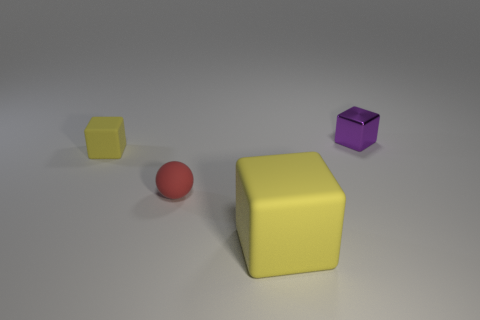Subtract all tiny yellow matte cubes. How many cubes are left? 2 Add 3 small gray rubber objects. How many objects exist? 7 Subtract all spheres. How many objects are left? 3 Subtract all purple cubes. How many cubes are left? 2 Subtract 1 spheres. How many spheres are left? 0 Subtract all green spheres. Subtract all red cubes. How many spheres are left? 1 Subtract all brown cubes. How many brown balls are left? 0 Subtract all red balls. Subtract all small purple things. How many objects are left? 2 Add 3 large rubber cubes. How many large rubber cubes are left? 4 Add 4 tiny purple matte spheres. How many tiny purple matte spheres exist? 4 